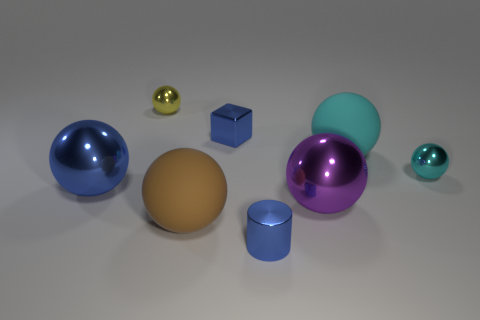Which objects in the image appear to have a matte surface as opposed to a reflective one? The large, central sphere exhibits a matte finish, contrasting with the other objects which have reflective surfaces. 